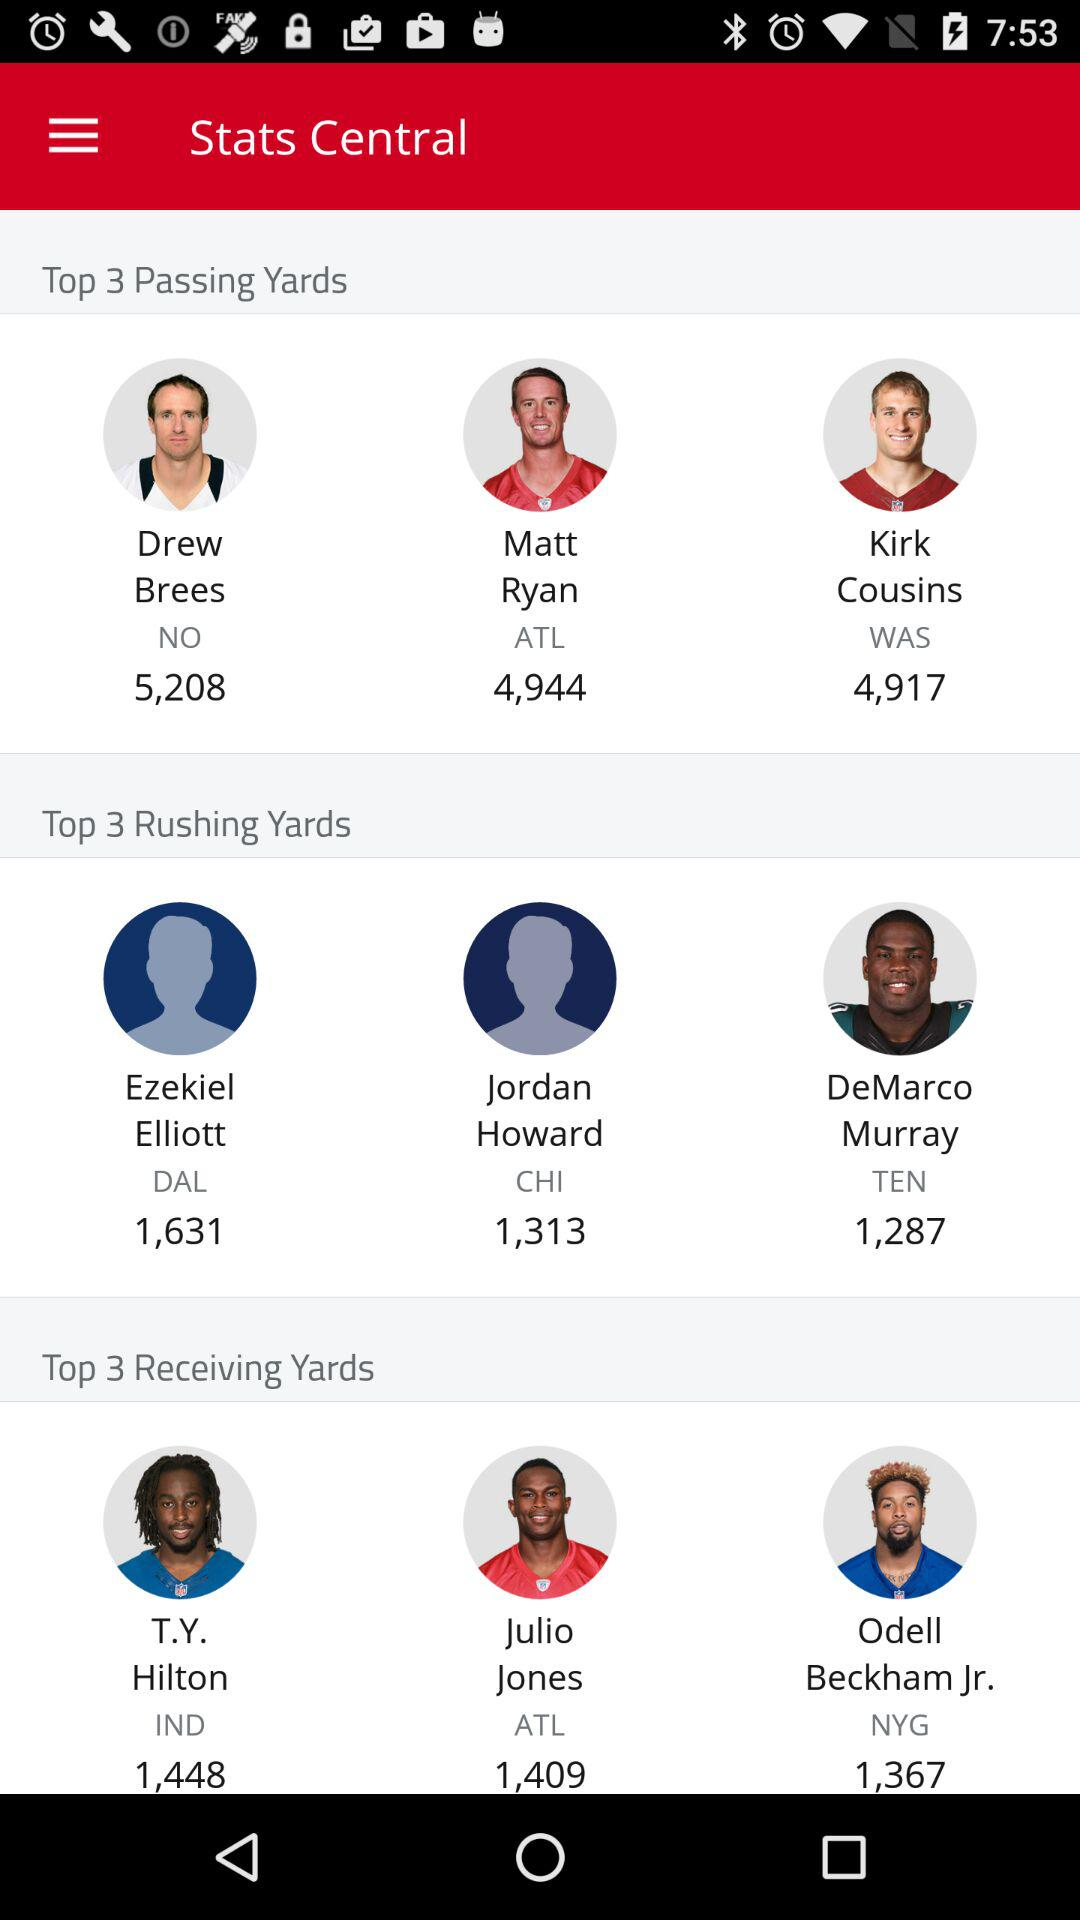What are the passing yards of Drew Brees? Drew Brees has 5,208 passing yards. 